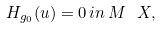<formula> <loc_0><loc_0><loc_500><loc_500>H _ { g _ { 0 } } ( u ) = 0 \, i n \, M \ X ,</formula> 